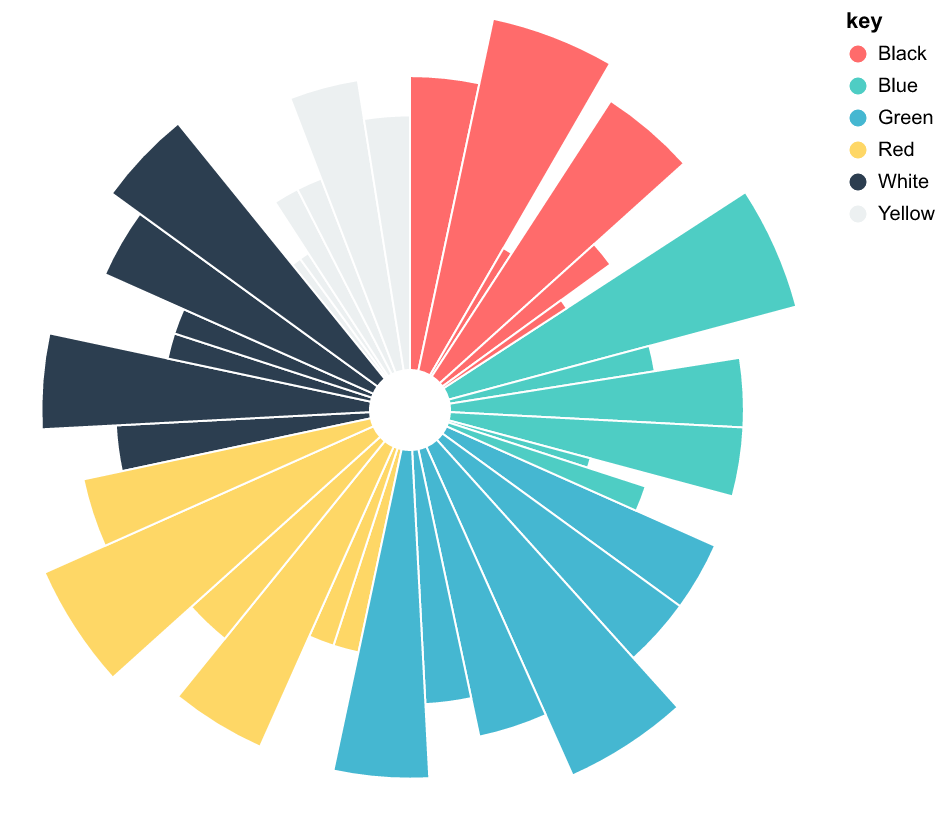What's the title of the chart? The title of the chart is usually placed at the top center, clearly indicating the subject of the visualization. By examining the given data and the context of the described figure, the title should relate to color schemes in traditional art across different regions.
Answer: Allocation of Color Schemes in Traditional Art Across Different Regions Which region has the highest utilization of Red color? By analyzing the given percentages of Red for each region, we need to find the highest value. The regions and corresponding values are: China (10), Japan (10), India (25), Middle East (15), Africa (30), and Latin America (20). The highest value is 30 in Africa.
Answer: Africa What is the combined percentage of Red and Yellow in India? The task requires summing the values for Red and Yellow in India. According to the data, India has 25% Red and 10% Yellow. Adding these gives a total of 25 + 10 = 35.
Answer: 35 Which color is equally utilized in both Japan and the Middle East? By comparing the color values for Japan and the Middle East, we find that the Red color is used at 10% in both regions.
Answer: Red How does the utilization of Green differ between China and Latin America? We need to calculate the difference between the values for Green color in these two regions. For China, Green is 20%, and for Latin America, it is 25%. The difference is 25 - 20 = 5.
Answer: 5 Which region has the most balanced use of all six colors? Observe the percentages of each color in all regions and identify which has the most similar values across all six colors. Japan shows relatively balanced values with 10, 20, 10, 5, 30, 25. Other regions have more variation.
Answer: Japan What is the range of White color utilization across all regions? The range is found by subtracting the lowest utilization from the highest. The utilization of White ranges from 10% in India and the Middle East to 25% in Japan and Latin America. The range is 25 - 10 = 15.
Answer: 15 Which two regions have the same value for Black color? By examining the percentages for Black across different regions, it is found that both China and Africa have 20% utilization of Black.
Answer: China and Africa Which region has the highest sum of Red, Blue, and Green? Calculate the sum of Red, Blue, and Green for each region and compare. China: 10+30+20=60, Japan: 10+10+20=40, India: 25+20+30=75, Middle East: 15+20+20=55, Africa: 30+5+15=50, Latin America: 20+10+25=55. India has the highest sum.
Answer: India What percentage of the total color utilization does Yellow represent in Maasai Beading? First, calculate the total color utilization in Maasai Beading: 30+15+5+20+10+20 = 100. The value for Yellow is 20. The percentage is (20/100) * 100 = 20%.
Answer: 20 